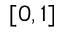<formula> <loc_0><loc_0><loc_500><loc_500>[ 0 , 1 ]</formula> 